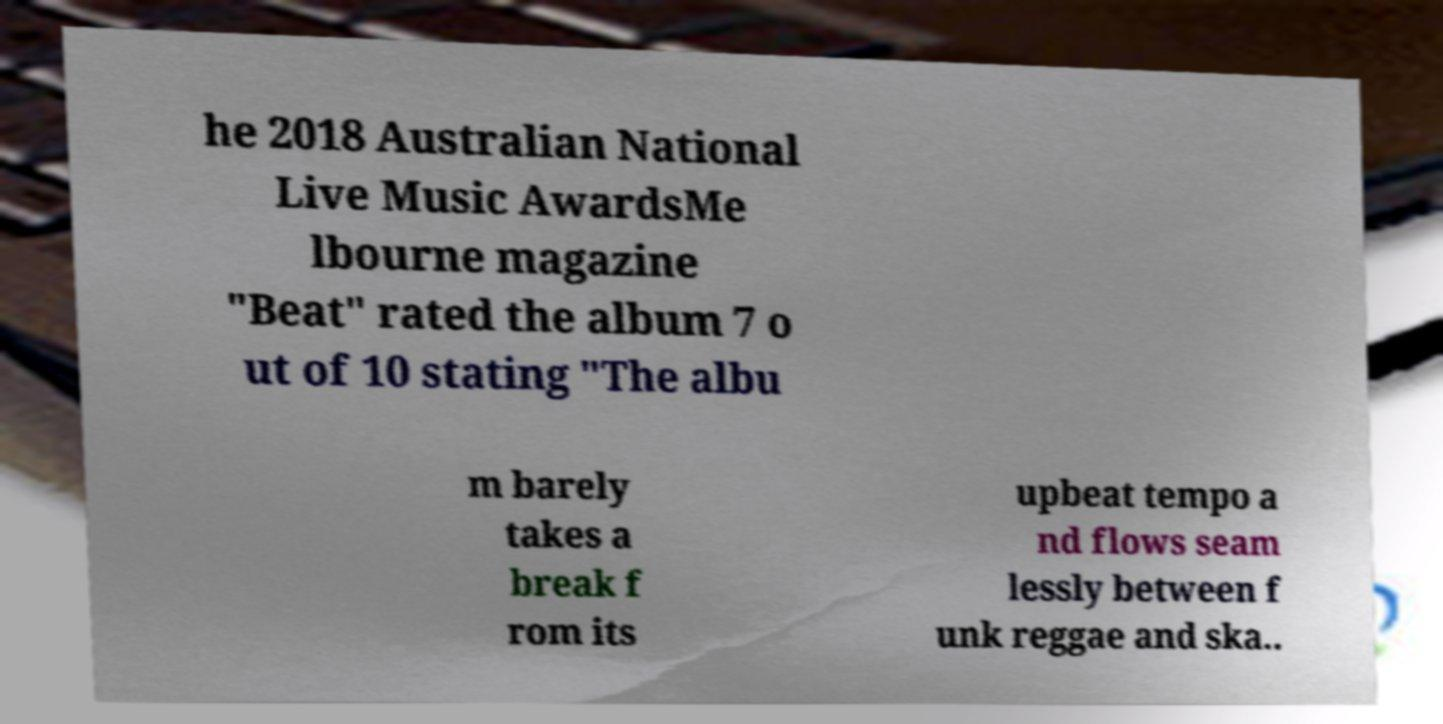Can you accurately transcribe the text from the provided image for me? he 2018 Australian National Live Music AwardsMe lbourne magazine "Beat" rated the album 7 o ut of 10 stating "The albu m barely takes a break f rom its upbeat tempo a nd flows seam lessly between f unk reggae and ska.. 